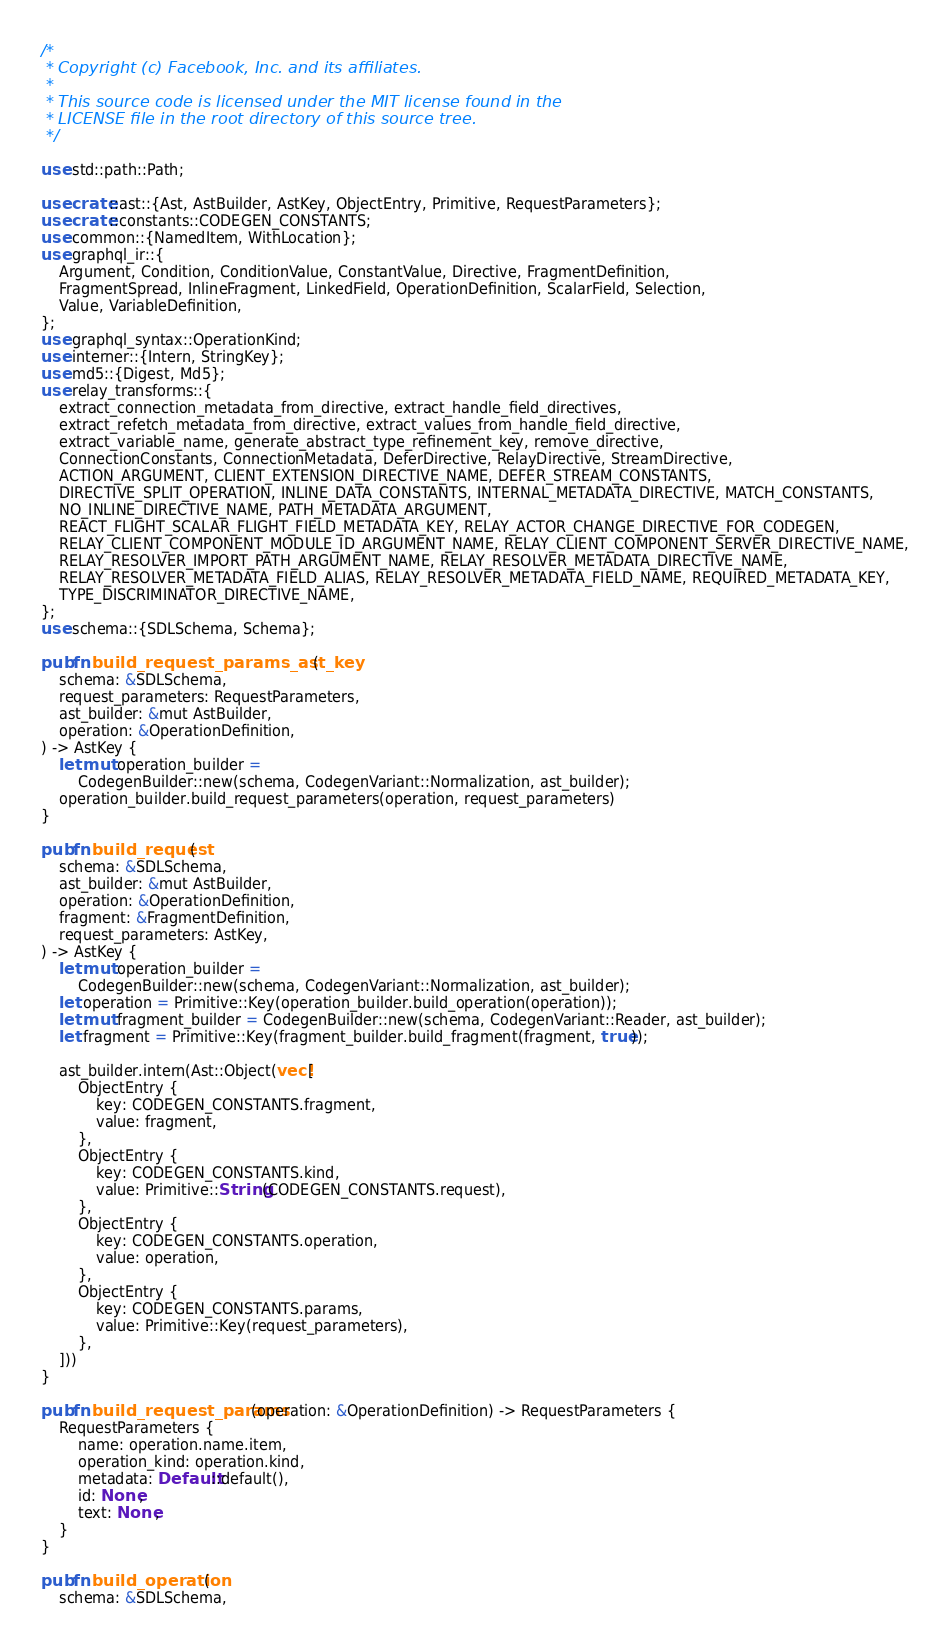Convert code to text. <code><loc_0><loc_0><loc_500><loc_500><_Rust_>/*
 * Copyright (c) Facebook, Inc. and its affiliates.
 *
 * This source code is licensed under the MIT license found in the
 * LICENSE file in the root directory of this source tree.
 */

use std::path::Path;

use crate::ast::{Ast, AstBuilder, AstKey, ObjectEntry, Primitive, RequestParameters};
use crate::constants::CODEGEN_CONSTANTS;
use common::{NamedItem, WithLocation};
use graphql_ir::{
    Argument, Condition, ConditionValue, ConstantValue, Directive, FragmentDefinition,
    FragmentSpread, InlineFragment, LinkedField, OperationDefinition, ScalarField, Selection,
    Value, VariableDefinition,
};
use graphql_syntax::OperationKind;
use interner::{Intern, StringKey};
use md5::{Digest, Md5};
use relay_transforms::{
    extract_connection_metadata_from_directive, extract_handle_field_directives,
    extract_refetch_metadata_from_directive, extract_values_from_handle_field_directive,
    extract_variable_name, generate_abstract_type_refinement_key, remove_directive,
    ConnectionConstants, ConnectionMetadata, DeferDirective, RelayDirective, StreamDirective,
    ACTION_ARGUMENT, CLIENT_EXTENSION_DIRECTIVE_NAME, DEFER_STREAM_CONSTANTS,
    DIRECTIVE_SPLIT_OPERATION, INLINE_DATA_CONSTANTS, INTERNAL_METADATA_DIRECTIVE, MATCH_CONSTANTS,
    NO_INLINE_DIRECTIVE_NAME, PATH_METADATA_ARGUMENT,
    REACT_FLIGHT_SCALAR_FLIGHT_FIELD_METADATA_KEY, RELAY_ACTOR_CHANGE_DIRECTIVE_FOR_CODEGEN,
    RELAY_CLIENT_COMPONENT_MODULE_ID_ARGUMENT_NAME, RELAY_CLIENT_COMPONENT_SERVER_DIRECTIVE_NAME,
    RELAY_RESOLVER_IMPORT_PATH_ARGUMENT_NAME, RELAY_RESOLVER_METADATA_DIRECTIVE_NAME,
    RELAY_RESOLVER_METADATA_FIELD_ALIAS, RELAY_RESOLVER_METADATA_FIELD_NAME, REQUIRED_METADATA_KEY,
    TYPE_DISCRIMINATOR_DIRECTIVE_NAME,
};
use schema::{SDLSchema, Schema};

pub fn build_request_params_ast_key(
    schema: &SDLSchema,
    request_parameters: RequestParameters,
    ast_builder: &mut AstBuilder,
    operation: &OperationDefinition,
) -> AstKey {
    let mut operation_builder =
        CodegenBuilder::new(schema, CodegenVariant::Normalization, ast_builder);
    operation_builder.build_request_parameters(operation, request_parameters)
}

pub fn build_request(
    schema: &SDLSchema,
    ast_builder: &mut AstBuilder,
    operation: &OperationDefinition,
    fragment: &FragmentDefinition,
    request_parameters: AstKey,
) -> AstKey {
    let mut operation_builder =
        CodegenBuilder::new(schema, CodegenVariant::Normalization, ast_builder);
    let operation = Primitive::Key(operation_builder.build_operation(operation));
    let mut fragment_builder = CodegenBuilder::new(schema, CodegenVariant::Reader, ast_builder);
    let fragment = Primitive::Key(fragment_builder.build_fragment(fragment, true));

    ast_builder.intern(Ast::Object(vec![
        ObjectEntry {
            key: CODEGEN_CONSTANTS.fragment,
            value: fragment,
        },
        ObjectEntry {
            key: CODEGEN_CONSTANTS.kind,
            value: Primitive::String(CODEGEN_CONSTANTS.request),
        },
        ObjectEntry {
            key: CODEGEN_CONSTANTS.operation,
            value: operation,
        },
        ObjectEntry {
            key: CODEGEN_CONSTANTS.params,
            value: Primitive::Key(request_parameters),
        },
    ]))
}

pub fn build_request_params(operation: &OperationDefinition) -> RequestParameters {
    RequestParameters {
        name: operation.name.item,
        operation_kind: operation.kind,
        metadata: Default::default(),
        id: None,
        text: None,
    }
}

pub fn build_operation(
    schema: &SDLSchema,</code> 